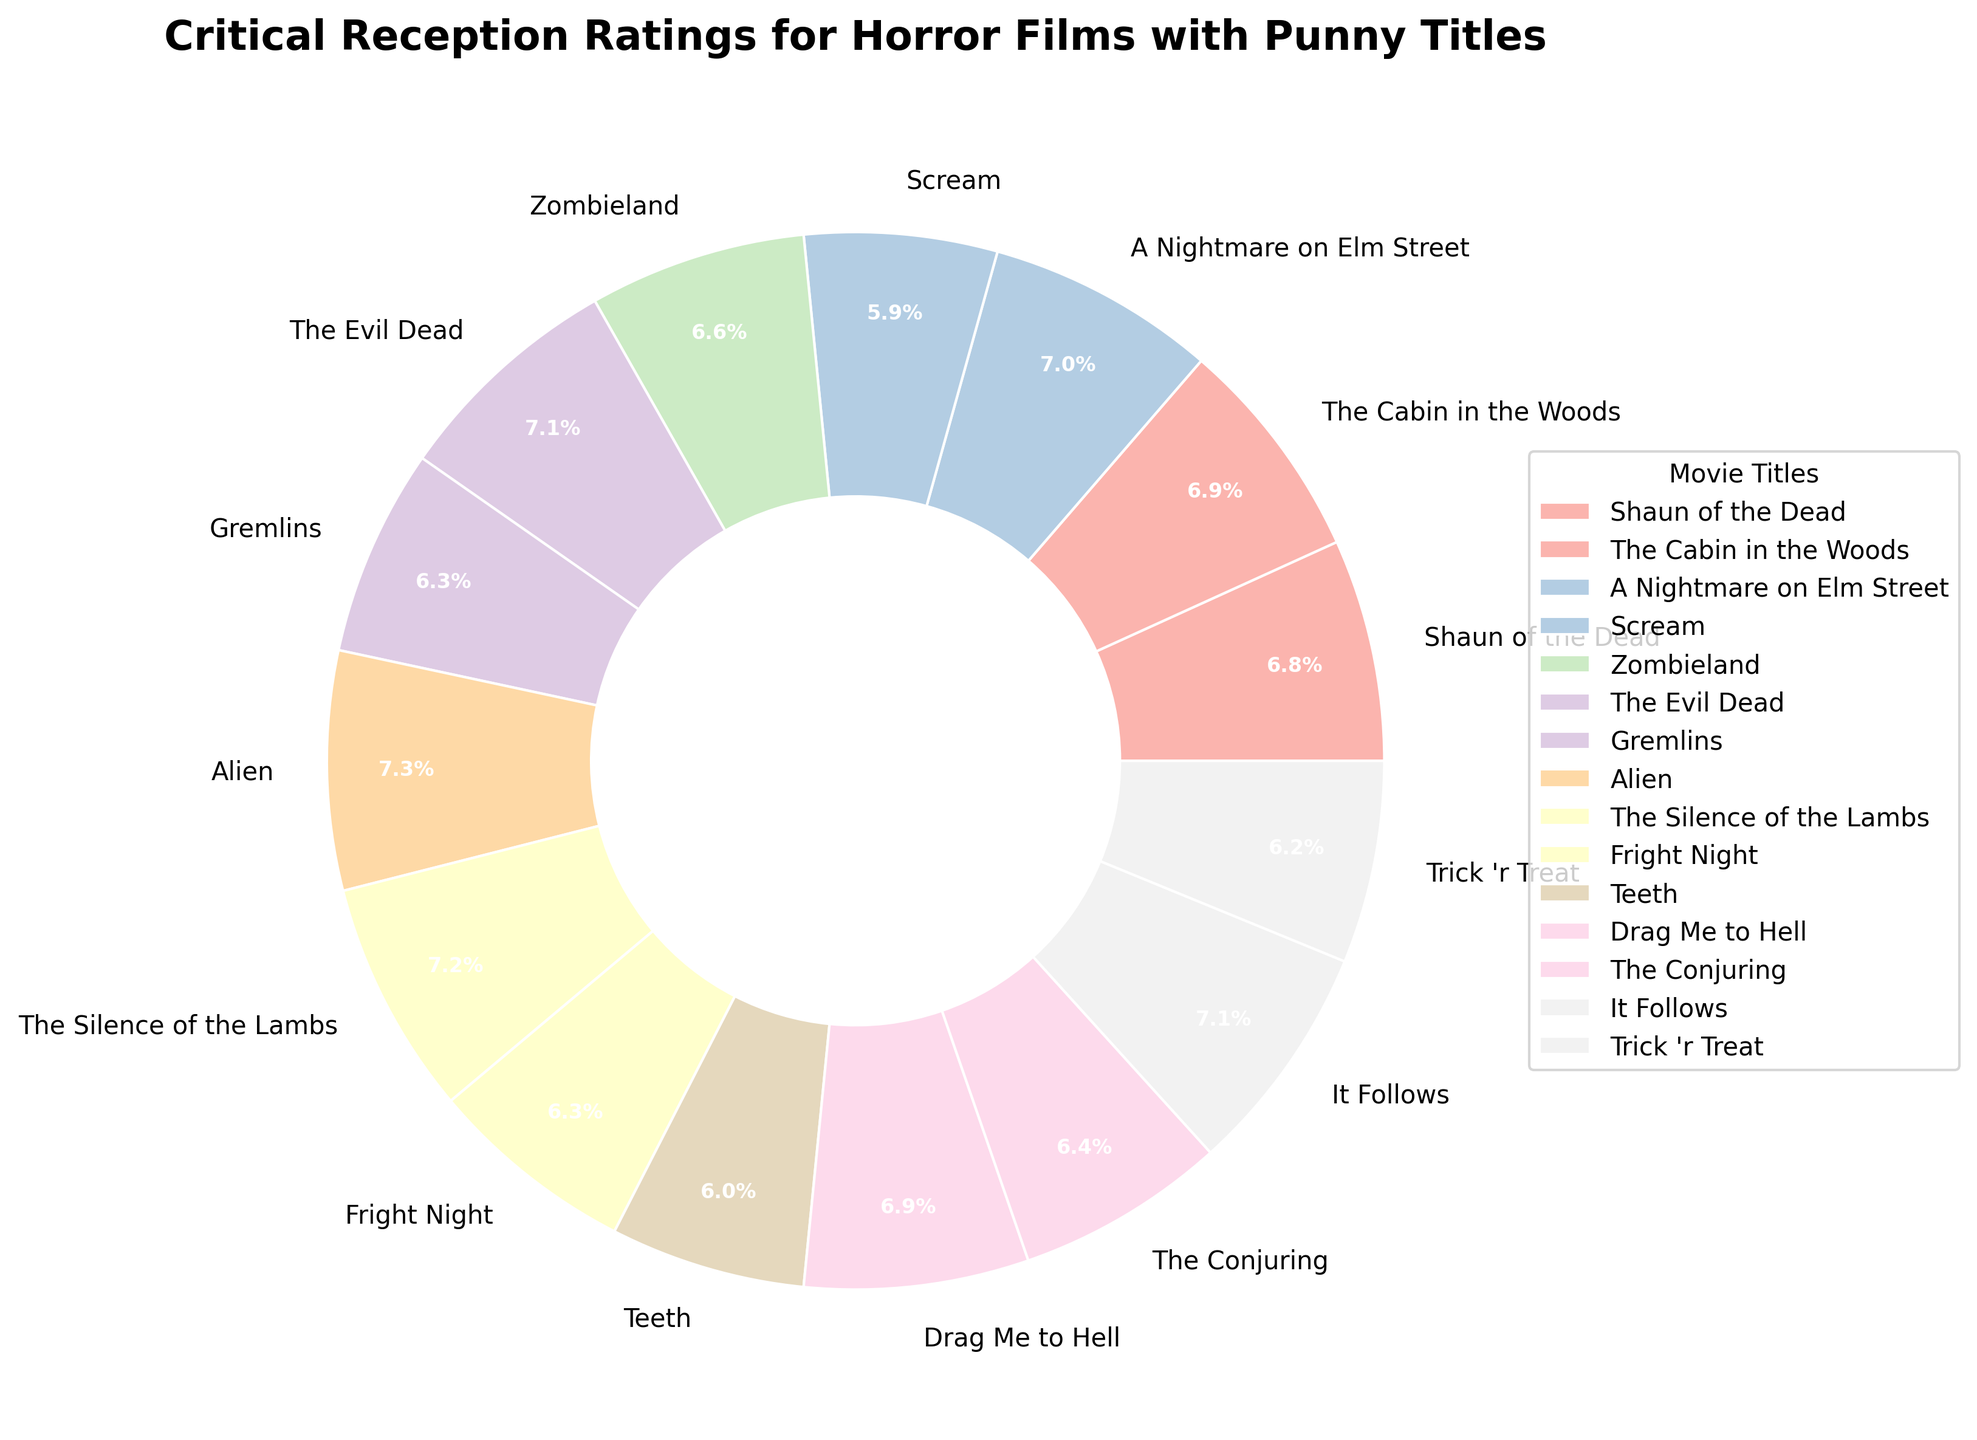Which movie received the highest critical reception rating? By examining the pie chart, we look for the largest segment or the one labeled with the highest percentage. "Alien" shows the highest rating with the largest segment and a 98% label.
Answer: Alien What is the combined percentage of "Shaun of the Dead" and "The Cabin in the Woods"? Each movie's percentage is directly labeled on the pie chart. "Shaun of the Dead" is 91%, and "The Cabin in the Woods" is 92%. Adding these together gives 91% + 92% = 183%.
Answer: 183% Which movie received a better reception, "Scream" or "Teeth"? We compare the two respective segments on the pie chart. "Scream" has a rating of 79%, while "Teeth" has a rating of 80%. Therefore, "Teeth" received a better reception.
Answer: Teeth How many movies have a rating of 90% or higher? We count the number of segments in the pie chart that have labels of 90% or above. These are "Shaun of the Dead," "The Cabin in the Woods," "A Nightmare on Elm Street," "The Evil Dead," "Alien," "The Silence of the Lambs," "Drag Me to Hell," and "It Follows," which totals to 8 movies.
Answer: 8 Which two movies have identical critical reception ratings, and what is that rating? By carefully scanning the chart for duplicate percentages, we find that "Gremlins" and "Fright Night" both have segments labeled 85%.
Answer: Gremlins and Fright Night with 85% What is the average rating of all the movies listed? Adding all the ratings and dividing by the number of movies: (91 + 92 + 94 + 79 + 89 + 95 + 85 + 98 + 96 + 85 + 80 + 92 + 86 + 95 + 83) / 15 = 1330 / 15 = 88.67%.
Answer: 88.67% Between "The Conjuring" and "Trick 'r Treat", which film has a lower rating? We compare the two segments on the pie chart. "The Conjuring" has a rating of 86%, while "Trick 'r Treat" has a rating of 83%. Thus, "Trick 'r Treat" has the lower rating.
Answer: Trick 'r Treat What's the difference in rating between the highest and lowest rated movies? We identify the highest rating as 98% for "Alien", and the lowest rating as 79% for "Scream". The difference is 98% - 79% = 19%.
Answer: 19% What is the combined rating percentage for "Scream", "Teeth", and "Trick 'r Treat"? Adding up the ratings for these three movies: 79% + 80% + 83% = 242%.
Answer: 242% What color is the segment for "The Evil Dead" in the pie chart? Observing the pie chart, the color for the segment labeled "The Evil Dead" is identifiable in the palette used (Pastel1), which shows a light, pastel shade for each movie. "The Evil Dead" is shown specifically in a pale green color.
Answer: pale green 